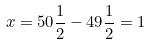<formula> <loc_0><loc_0><loc_500><loc_500>x = 5 0 \frac { 1 } { 2 } - 4 9 \frac { 1 } { 2 } = 1</formula> 